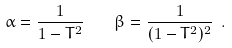Convert formula to latex. <formula><loc_0><loc_0><loc_500><loc_500>\alpha = \frac { 1 } { 1 - T ^ { 2 } } \quad \beta = \frac { 1 } { ( 1 - T ^ { 2 } ) ^ { 2 } } \ .</formula> 